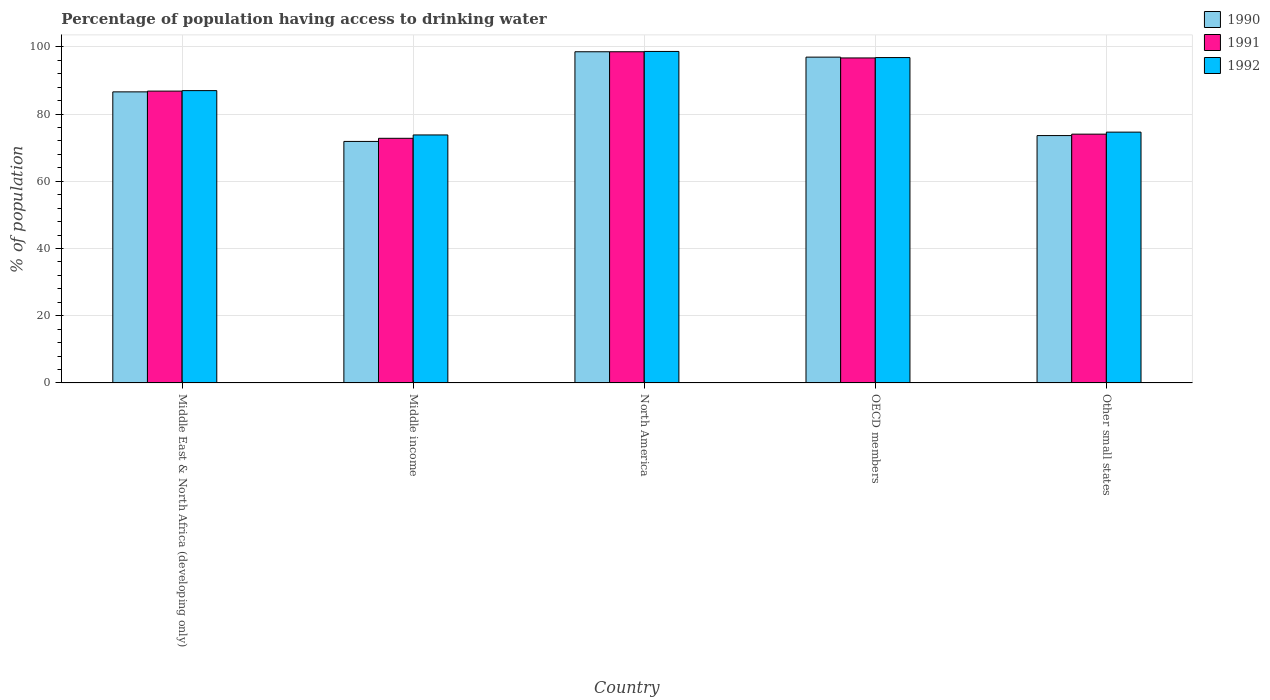How many different coloured bars are there?
Your response must be concise. 3. How many groups of bars are there?
Offer a terse response. 5. Are the number of bars on each tick of the X-axis equal?
Make the answer very short. Yes. How many bars are there on the 4th tick from the left?
Your answer should be very brief. 3. In how many cases, is the number of bars for a given country not equal to the number of legend labels?
Ensure brevity in your answer.  0. What is the percentage of population having access to drinking water in 1992 in North America?
Your answer should be compact. 98.63. Across all countries, what is the maximum percentage of population having access to drinking water in 1990?
Your answer should be very brief. 98.54. Across all countries, what is the minimum percentage of population having access to drinking water in 1991?
Give a very brief answer. 72.79. What is the total percentage of population having access to drinking water in 1992 in the graph?
Offer a very short reply. 430.83. What is the difference between the percentage of population having access to drinking water in 1990 in Middle income and that in North America?
Your answer should be very brief. -26.68. What is the difference between the percentage of population having access to drinking water in 1990 in Middle East & North Africa (developing only) and the percentage of population having access to drinking water in 1991 in OECD members?
Offer a terse response. -10.09. What is the average percentage of population having access to drinking water in 1992 per country?
Give a very brief answer. 86.17. What is the difference between the percentage of population having access to drinking water of/in 1992 and percentage of population having access to drinking water of/in 1990 in Middle income?
Keep it short and to the point. 1.93. In how many countries, is the percentage of population having access to drinking water in 1991 greater than 96 %?
Give a very brief answer. 2. What is the ratio of the percentage of population having access to drinking water in 1992 in Middle East & North Africa (developing only) to that in North America?
Provide a short and direct response. 0.88. Is the percentage of population having access to drinking water in 1992 in OECD members less than that in Other small states?
Ensure brevity in your answer.  No. Is the difference between the percentage of population having access to drinking water in 1992 in Middle income and North America greater than the difference between the percentage of population having access to drinking water in 1990 in Middle income and North America?
Ensure brevity in your answer.  Yes. What is the difference between the highest and the second highest percentage of population having access to drinking water in 1990?
Offer a terse response. -1.6. What is the difference between the highest and the lowest percentage of population having access to drinking water in 1992?
Your answer should be very brief. 24.84. Is the sum of the percentage of population having access to drinking water in 1992 in Middle East & North Africa (developing only) and North America greater than the maximum percentage of population having access to drinking water in 1991 across all countries?
Offer a terse response. Yes. What does the 2nd bar from the left in OECD members represents?
Offer a very short reply. 1991. Are all the bars in the graph horizontal?
Ensure brevity in your answer.  No. How many countries are there in the graph?
Your answer should be very brief. 5. Are the values on the major ticks of Y-axis written in scientific E-notation?
Offer a very short reply. No. Does the graph contain any zero values?
Your answer should be compact. No. What is the title of the graph?
Give a very brief answer. Percentage of population having access to drinking water. Does "1972" appear as one of the legend labels in the graph?
Give a very brief answer. No. What is the label or title of the X-axis?
Ensure brevity in your answer.  Country. What is the label or title of the Y-axis?
Ensure brevity in your answer.  % of population. What is the % of population in 1990 in Middle East & North Africa (developing only)?
Give a very brief answer. 86.61. What is the % of population in 1991 in Middle East & North Africa (developing only)?
Provide a succinct answer. 86.83. What is the % of population in 1992 in Middle East & North Africa (developing only)?
Your answer should be compact. 86.98. What is the % of population in 1990 in Middle income?
Your answer should be very brief. 71.86. What is the % of population in 1991 in Middle income?
Offer a very short reply. 72.79. What is the % of population in 1992 in Middle income?
Your answer should be very brief. 73.79. What is the % of population of 1990 in North America?
Your response must be concise. 98.54. What is the % of population in 1991 in North America?
Provide a short and direct response. 98.54. What is the % of population in 1992 in North America?
Your answer should be very brief. 98.63. What is the % of population in 1990 in OECD members?
Give a very brief answer. 96.94. What is the % of population of 1991 in OECD members?
Your answer should be very brief. 96.7. What is the % of population in 1992 in OECD members?
Your answer should be very brief. 96.81. What is the % of population in 1990 in Other small states?
Keep it short and to the point. 73.6. What is the % of population of 1991 in Other small states?
Provide a succinct answer. 74.03. What is the % of population in 1992 in Other small states?
Make the answer very short. 74.63. Across all countries, what is the maximum % of population of 1990?
Give a very brief answer. 98.54. Across all countries, what is the maximum % of population of 1991?
Give a very brief answer. 98.54. Across all countries, what is the maximum % of population in 1992?
Offer a terse response. 98.63. Across all countries, what is the minimum % of population in 1990?
Make the answer very short. 71.86. Across all countries, what is the minimum % of population of 1991?
Your response must be concise. 72.79. Across all countries, what is the minimum % of population of 1992?
Your response must be concise. 73.79. What is the total % of population of 1990 in the graph?
Make the answer very short. 427.54. What is the total % of population in 1991 in the graph?
Offer a very short reply. 428.88. What is the total % of population in 1992 in the graph?
Offer a terse response. 430.83. What is the difference between the % of population of 1990 in Middle East & North Africa (developing only) and that in Middle income?
Give a very brief answer. 14.75. What is the difference between the % of population of 1991 in Middle East & North Africa (developing only) and that in Middle income?
Ensure brevity in your answer.  14.04. What is the difference between the % of population in 1992 in Middle East & North Africa (developing only) and that in Middle income?
Provide a short and direct response. 13.19. What is the difference between the % of population in 1990 in Middle East & North Africa (developing only) and that in North America?
Provide a succinct answer. -11.93. What is the difference between the % of population in 1991 in Middle East & North Africa (developing only) and that in North America?
Make the answer very short. -11.71. What is the difference between the % of population in 1992 in Middle East & North Africa (developing only) and that in North America?
Keep it short and to the point. -11.65. What is the difference between the % of population of 1990 in Middle East & North Africa (developing only) and that in OECD members?
Your answer should be very brief. -10.33. What is the difference between the % of population of 1991 in Middle East & North Africa (developing only) and that in OECD members?
Keep it short and to the point. -9.87. What is the difference between the % of population of 1992 in Middle East & North Africa (developing only) and that in OECD members?
Provide a succinct answer. -9.84. What is the difference between the % of population in 1990 in Middle East & North Africa (developing only) and that in Other small states?
Your response must be concise. 13.01. What is the difference between the % of population in 1991 in Middle East & North Africa (developing only) and that in Other small states?
Give a very brief answer. 12.8. What is the difference between the % of population in 1992 in Middle East & North Africa (developing only) and that in Other small states?
Offer a very short reply. 12.35. What is the difference between the % of population of 1990 in Middle income and that in North America?
Provide a succinct answer. -26.68. What is the difference between the % of population of 1991 in Middle income and that in North America?
Offer a very short reply. -25.75. What is the difference between the % of population of 1992 in Middle income and that in North America?
Offer a terse response. -24.84. What is the difference between the % of population of 1990 in Middle income and that in OECD members?
Keep it short and to the point. -25.08. What is the difference between the % of population in 1991 in Middle income and that in OECD members?
Offer a terse response. -23.91. What is the difference between the % of population in 1992 in Middle income and that in OECD members?
Make the answer very short. -23.02. What is the difference between the % of population in 1990 in Middle income and that in Other small states?
Your response must be concise. -1.74. What is the difference between the % of population of 1991 in Middle income and that in Other small states?
Your answer should be compact. -1.24. What is the difference between the % of population in 1992 in Middle income and that in Other small states?
Provide a short and direct response. -0.84. What is the difference between the % of population in 1990 in North America and that in OECD members?
Your answer should be compact. 1.6. What is the difference between the % of population in 1991 in North America and that in OECD members?
Offer a terse response. 1.84. What is the difference between the % of population in 1992 in North America and that in OECD members?
Give a very brief answer. 1.82. What is the difference between the % of population in 1990 in North America and that in Other small states?
Provide a succinct answer. 24.94. What is the difference between the % of population in 1991 in North America and that in Other small states?
Keep it short and to the point. 24.52. What is the difference between the % of population of 1992 in North America and that in Other small states?
Your answer should be very brief. 24. What is the difference between the % of population of 1990 in OECD members and that in Other small states?
Offer a very short reply. 23.34. What is the difference between the % of population of 1991 in OECD members and that in Other small states?
Keep it short and to the point. 22.67. What is the difference between the % of population of 1992 in OECD members and that in Other small states?
Your response must be concise. 22.19. What is the difference between the % of population of 1990 in Middle East & North Africa (developing only) and the % of population of 1991 in Middle income?
Ensure brevity in your answer.  13.82. What is the difference between the % of population in 1990 in Middle East & North Africa (developing only) and the % of population in 1992 in Middle income?
Give a very brief answer. 12.82. What is the difference between the % of population in 1991 in Middle East & North Africa (developing only) and the % of population in 1992 in Middle income?
Your answer should be compact. 13.04. What is the difference between the % of population in 1990 in Middle East & North Africa (developing only) and the % of population in 1991 in North America?
Your answer should be very brief. -11.93. What is the difference between the % of population of 1990 in Middle East & North Africa (developing only) and the % of population of 1992 in North America?
Offer a terse response. -12.02. What is the difference between the % of population in 1991 in Middle East & North Africa (developing only) and the % of population in 1992 in North America?
Keep it short and to the point. -11.8. What is the difference between the % of population in 1990 in Middle East & North Africa (developing only) and the % of population in 1991 in OECD members?
Your answer should be very brief. -10.09. What is the difference between the % of population in 1990 in Middle East & North Africa (developing only) and the % of population in 1992 in OECD members?
Offer a terse response. -10.21. What is the difference between the % of population of 1991 in Middle East & North Africa (developing only) and the % of population of 1992 in OECD members?
Your answer should be compact. -9.98. What is the difference between the % of population of 1990 in Middle East & North Africa (developing only) and the % of population of 1991 in Other small states?
Keep it short and to the point. 12.58. What is the difference between the % of population of 1990 in Middle East & North Africa (developing only) and the % of population of 1992 in Other small states?
Offer a terse response. 11.98. What is the difference between the % of population of 1991 in Middle East & North Africa (developing only) and the % of population of 1992 in Other small states?
Make the answer very short. 12.2. What is the difference between the % of population in 1990 in Middle income and the % of population in 1991 in North America?
Offer a very short reply. -26.68. What is the difference between the % of population of 1990 in Middle income and the % of population of 1992 in North America?
Keep it short and to the point. -26.77. What is the difference between the % of population in 1991 in Middle income and the % of population in 1992 in North America?
Your answer should be very brief. -25.84. What is the difference between the % of population in 1990 in Middle income and the % of population in 1991 in OECD members?
Give a very brief answer. -24.84. What is the difference between the % of population in 1990 in Middle income and the % of population in 1992 in OECD members?
Your answer should be compact. -24.95. What is the difference between the % of population of 1991 in Middle income and the % of population of 1992 in OECD members?
Ensure brevity in your answer.  -24.02. What is the difference between the % of population of 1990 in Middle income and the % of population of 1991 in Other small states?
Provide a short and direct response. -2.17. What is the difference between the % of population of 1990 in Middle income and the % of population of 1992 in Other small states?
Keep it short and to the point. -2.77. What is the difference between the % of population in 1991 in Middle income and the % of population in 1992 in Other small states?
Make the answer very short. -1.84. What is the difference between the % of population in 1990 in North America and the % of population in 1991 in OECD members?
Provide a succinct answer. 1.84. What is the difference between the % of population of 1990 in North America and the % of population of 1992 in OECD members?
Your response must be concise. 1.73. What is the difference between the % of population of 1991 in North America and the % of population of 1992 in OECD members?
Ensure brevity in your answer.  1.73. What is the difference between the % of population of 1990 in North America and the % of population of 1991 in Other small states?
Keep it short and to the point. 24.51. What is the difference between the % of population of 1990 in North America and the % of population of 1992 in Other small states?
Provide a succinct answer. 23.91. What is the difference between the % of population in 1991 in North America and the % of population in 1992 in Other small states?
Ensure brevity in your answer.  23.91. What is the difference between the % of population of 1990 in OECD members and the % of population of 1991 in Other small states?
Make the answer very short. 22.91. What is the difference between the % of population in 1990 in OECD members and the % of population in 1992 in Other small states?
Your answer should be very brief. 22.31. What is the difference between the % of population in 1991 in OECD members and the % of population in 1992 in Other small states?
Ensure brevity in your answer.  22.07. What is the average % of population of 1990 per country?
Your answer should be compact. 85.51. What is the average % of population of 1991 per country?
Offer a very short reply. 85.78. What is the average % of population of 1992 per country?
Keep it short and to the point. 86.17. What is the difference between the % of population of 1990 and % of population of 1991 in Middle East & North Africa (developing only)?
Your response must be concise. -0.22. What is the difference between the % of population of 1990 and % of population of 1992 in Middle East & North Africa (developing only)?
Provide a succinct answer. -0.37. What is the difference between the % of population in 1991 and % of population in 1992 in Middle East & North Africa (developing only)?
Give a very brief answer. -0.15. What is the difference between the % of population of 1990 and % of population of 1991 in Middle income?
Your answer should be compact. -0.93. What is the difference between the % of population of 1990 and % of population of 1992 in Middle income?
Offer a terse response. -1.93. What is the difference between the % of population in 1991 and % of population in 1992 in Middle income?
Your response must be concise. -1. What is the difference between the % of population in 1990 and % of population in 1991 in North America?
Offer a very short reply. -0. What is the difference between the % of population in 1990 and % of population in 1992 in North America?
Your answer should be compact. -0.09. What is the difference between the % of population of 1991 and % of population of 1992 in North America?
Provide a short and direct response. -0.09. What is the difference between the % of population in 1990 and % of population in 1991 in OECD members?
Offer a terse response. 0.24. What is the difference between the % of population of 1990 and % of population of 1992 in OECD members?
Offer a very short reply. 0.13. What is the difference between the % of population of 1991 and % of population of 1992 in OECD members?
Offer a very short reply. -0.11. What is the difference between the % of population of 1990 and % of population of 1991 in Other small states?
Your response must be concise. -0.43. What is the difference between the % of population in 1990 and % of population in 1992 in Other small states?
Offer a very short reply. -1.03. What is the difference between the % of population in 1991 and % of population in 1992 in Other small states?
Offer a terse response. -0.6. What is the ratio of the % of population in 1990 in Middle East & North Africa (developing only) to that in Middle income?
Make the answer very short. 1.21. What is the ratio of the % of population in 1991 in Middle East & North Africa (developing only) to that in Middle income?
Ensure brevity in your answer.  1.19. What is the ratio of the % of population in 1992 in Middle East & North Africa (developing only) to that in Middle income?
Your response must be concise. 1.18. What is the ratio of the % of population in 1990 in Middle East & North Africa (developing only) to that in North America?
Your answer should be compact. 0.88. What is the ratio of the % of population of 1991 in Middle East & North Africa (developing only) to that in North America?
Offer a very short reply. 0.88. What is the ratio of the % of population in 1992 in Middle East & North Africa (developing only) to that in North America?
Offer a terse response. 0.88. What is the ratio of the % of population in 1990 in Middle East & North Africa (developing only) to that in OECD members?
Provide a short and direct response. 0.89. What is the ratio of the % of population of 1991 in Middle East & North Africa (developing only) to that in OECD members?
Give a very brief answer. 0.9. What is the ratio of the % of population of 1992 in Middle East & North Africa (developing only) to that in OECD members?
Ensure brevity in your answer.  0.9. What is the ratio of the % of population of 1990 in Middle East & North Africa (developing only) to that in Other small states?
Your answer should be compact. 1.18. What is the ratio of the % of population in 1991 in Middle East & North Africa (developing only) to that in Other small states?
Your answer should be compact. 1.17. What is the ratio of the % of population in 1992 in Middle East & North Africa (developing only) to that in Other small states?
Make the answer very short. 1.17. What is the ratio of the % of population in 1990 in Middle income to that in North America?
Give a very brief answer. 0.73. What is the ratio of the % of population in 1991 in Middle income to that in North America?
Offer a terse response. 0.74. What is the ratio of the % of population in 1992 in Middle income to that in North America?
Provide a succinct answer. 0.75. What is the ratio of the % of population in 1990 in Middle income to that in OECD members?
Your answer should be very brief. 0.74. What is the ratio of the % of population of 1991 in Middle income to that in OECD members?
Offer a terse response. 0.75. What is the ratio of the % of population of 1992 in Middle income to that in OECD members?
Make the answer very short. 0.76. What is the ratio of the % of population in 1990 in Middle income to that in Other small states?
Give a very brief answer. 0.98. What is the ratio of the % of population in 1991 in Middle income to that in Other small states?
Your response must be concise. 0.98. What is the ratio of the % of population of 1990 in North America to that in OECD members?
Offer a very short reply. 1.02. What is the ratio of the % of population in 1991 in North America to that in OECD members?
Make the answer very short. 1.02. What is the ratio of the % of population in 1992 in North America to that in OECD members?
Make the answer very short. 1.02. What is the ratio of the % of population in 1990 in North America to that in Other small states?
Your answer should be very brief. 1.34. What is the ratio of the % of population in 1991 in North America to that in Other small states?
Your answer should be very brief. 1.33. What is the ratio of the % of population in 1992 in North America to that in Other small states?
Offer a terse response. 1.32. What is the ratio of the % of population of 1990 in OECD members to that in Other small states?
Your response must be concise. 1.32. What is the ratio of the % of population of 1991 in OECD members to that in Other small states?
Your answer should be very brief. 1.31. What is the ratio of the % of population of 1992 in OECD members to that in Other small states?
Your answer should be very brief. 1.3. What is the difference between the highest and the second highest % of population of 1990?
Offer a very short reply. 1.6. What is the difference between the highest and the second highest % of population of 1991?
Your answer should be very brief. 1.84. What is the difference between the highest and the second highest % of population in 1992?
Ensure brevity in your answer.  1.82. What is the difference between the highest and the lowest % of population in 1990?
Ensure brevity in your answer.  26.68. What is the difference between the highest and the lowest % of population in 1991?
Offer a very short reply. 25.75. What is the difference between the highest and the lowest % of population of 1992?
Give a very brief answer. 24.84. 